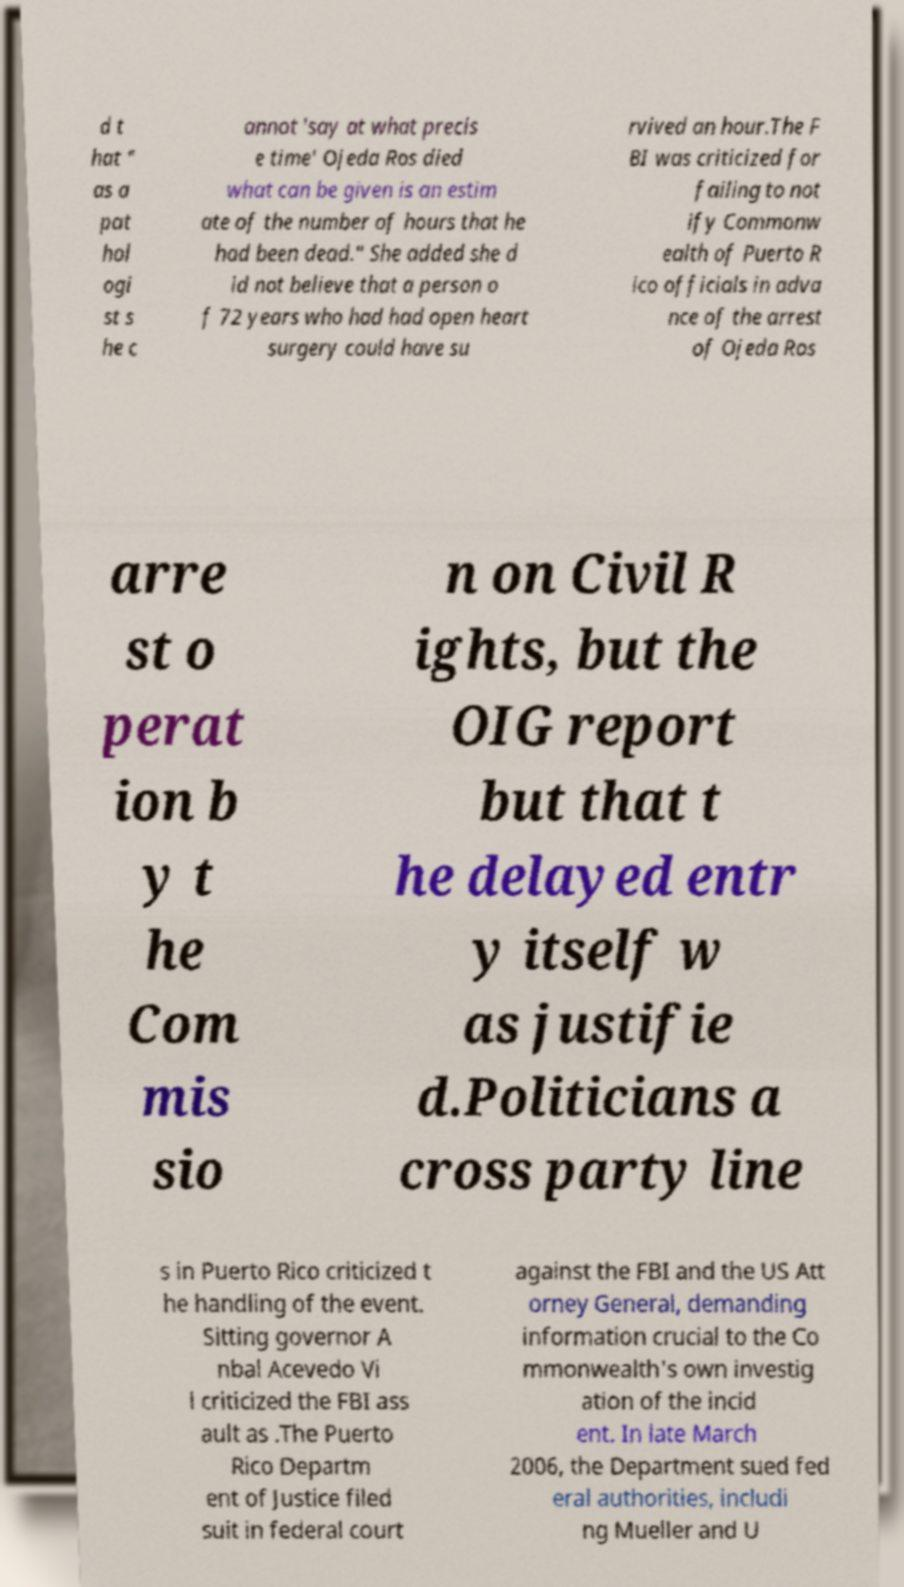Could you extract and type out the text from this image? d t hat " as a pat hol ogi st s he c annot 'say at what precis e time' Ojeda Ros died what can be given is an estim ate of the number of hours that he had been dead." She added she d id not believe that a person o f 72 years who had had open heart surgery could have su rvived an hour.The F BI was criticized for failing to not ify Commonw ealth of Puerto R ico officials in adva nce of the arrest of Ojeda Ros arre st o perat ion b y t he Com mis sio n on Civil R ights, but the OIG report but that t he delayed entr y itself w as justifie d.Politicians a cross party line s in Puerto Rico criticized t he handling of the event. Sitting governor A nbal Acevedo Vi l criticized the FBI ass ault as .The Puerto Rico Departm ent of Justice filed suit in federal court against the FBI and the US Att orney General, demanding information crucial to the Co mmonwealth's own investig ation of the incid ent. In late March 2006, the Department sued fed eral authorities, includi ng Mueller and U 